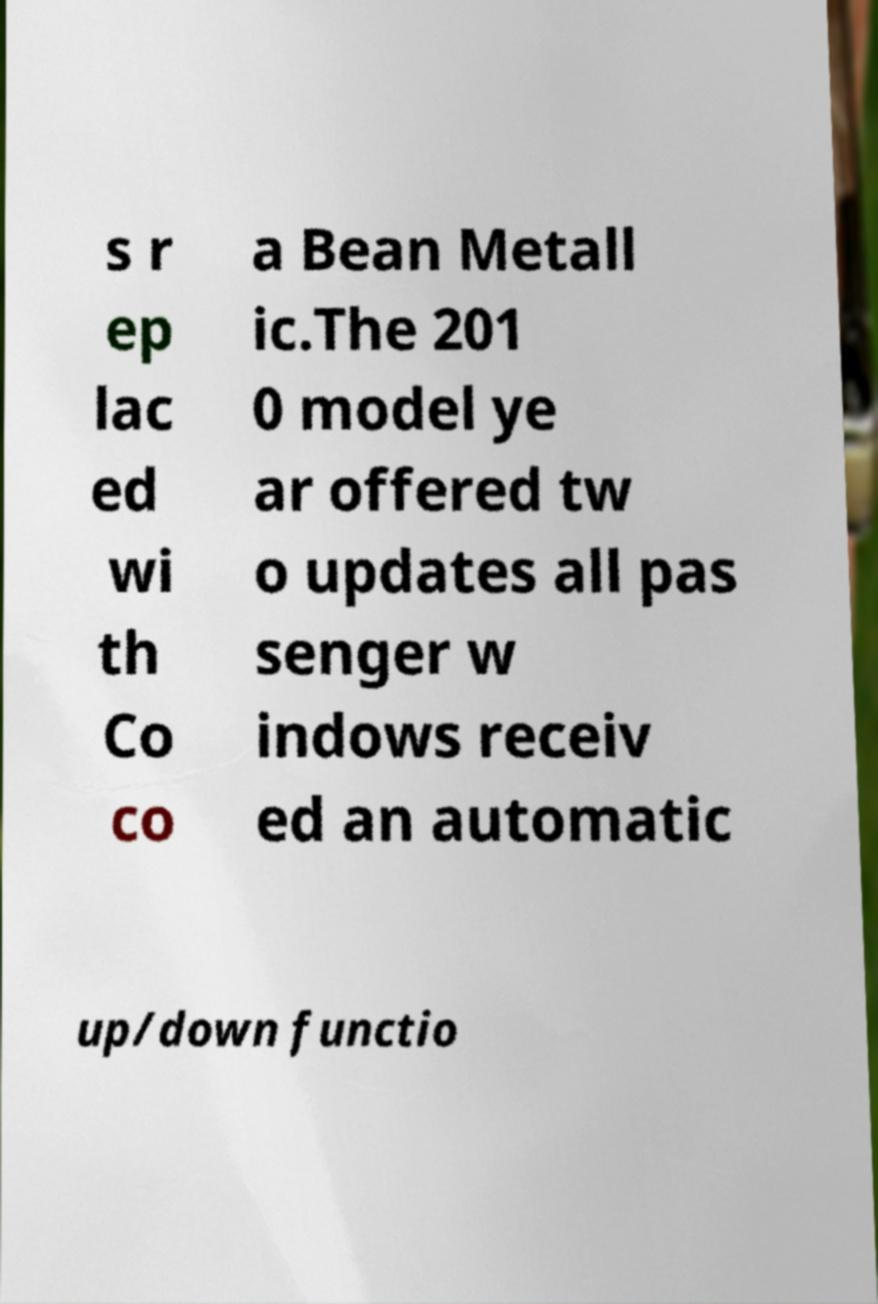Could you extract and type out the text from this image? s r ep lac ed wi th Co co a Bean Metall ic.The 201 0 model ye ar offered tw o updates all pas senger w indows receiv ed an automatic up/down functio 